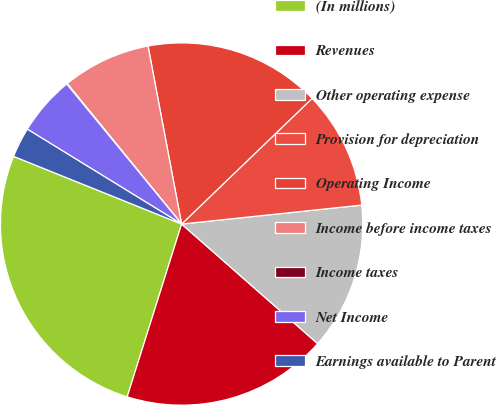Convert chart to OTSL. <chart><loc_0><loc_0><loc_500><loc_500><pie_chart><fcel>(In millions)<fcel>Revenues<fcel>Other operating expense<fcel>Provision for depreciation<fcel>Operating Income<fcel>Income before income taxes<fcel>Income taxes<fcel>Net Income<fcel>Earnings available to Parent<nl><fcel>26.24%<fcel>18.38%<fcel>13.15%<fcel>10.53%<fcel>15.77%<fcel>7.91%<fcel>0.06%<fcel>5.29%<fcel>2.68%<nl></chart> 